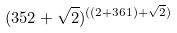<formula> <loc_0><loc_0><loc_500><loc_500>( 3 5 2 + \sqrt { 2 } ) ^ { ( ( 2 + 3 6 1 ) + \sqrt { 2 } ) }</formula> 